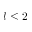<formula> <loc_0><loc_0><loc_500><loc_500>l \leq 2</formula> 